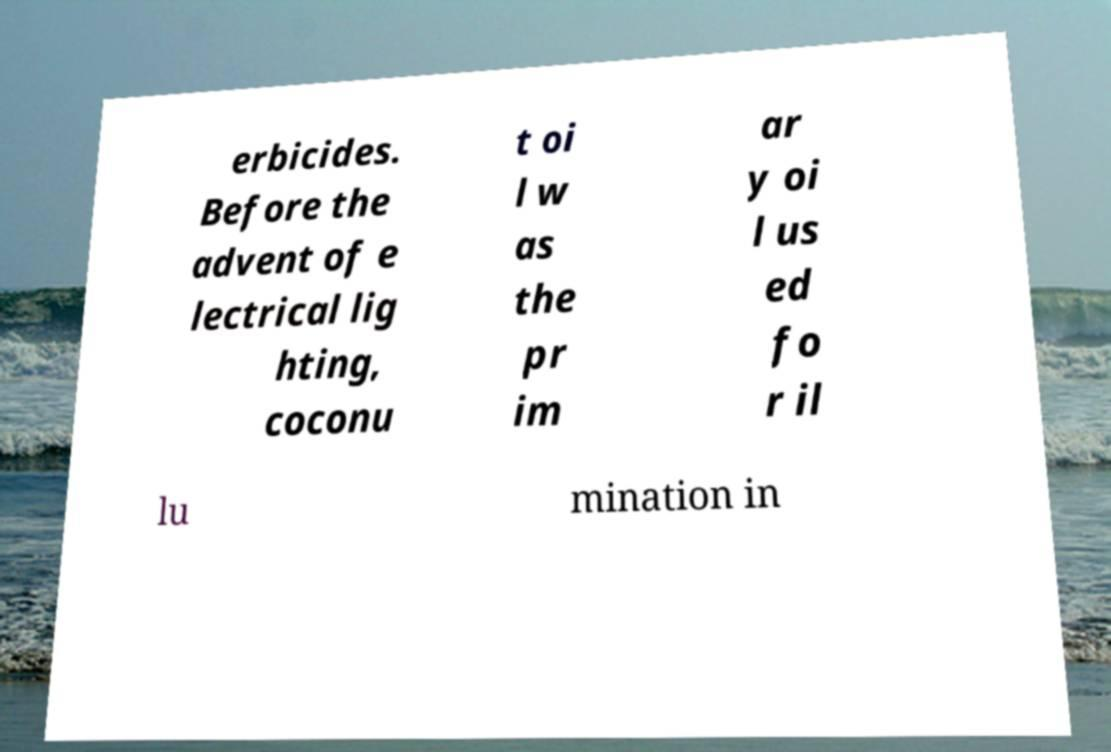Can you accurately transcribe the text from the provided image for me? erbicides. Before the advent of e lectrical lig hting, coconu t oi l w as the pr im ar y oi l us ed fo r il lu mination in 